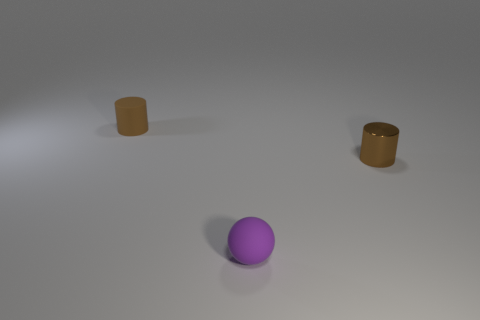Add 2 small rubber balls. How many objects exist? 5 Subtract 1 cylinders. How many cylinders are left? 1 Add 3 brown cylinders. How many brown cylinders are left? 5 Add 3 tiny matte objects. How many tiny matte objects exist? 5 Subtract 0 cyan blocks. How many objects are left? 3 Subtract all balls. How many objects are left? 2 Subtract all green cylinders. Subtract all red cubes. How many cylinders are left? 2 Subtract all small things. Subtract all small gray shiny objects. How many objects are left? 0 